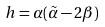Convert formula to latex. <formula><loc_0><loc_0><loc_500><loc_500>h = \alpha ( \tilde { \alpha } - 2 \beta )</formula> 